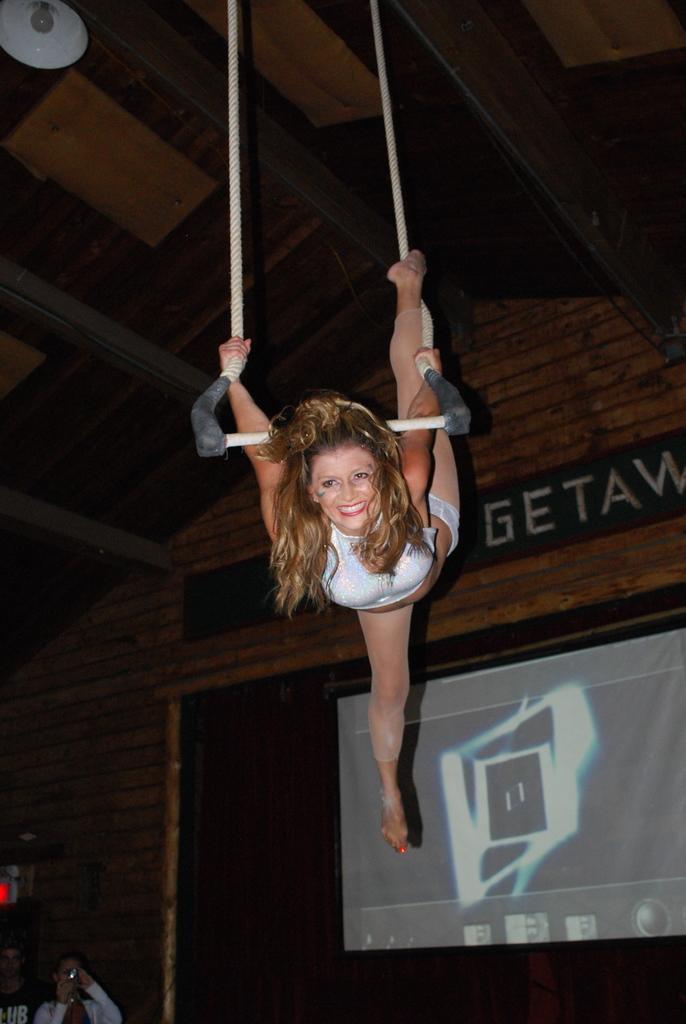Describe this image in one or two sentences. In this picture I can see there is a woman performing acrobatics and she is wearing a white dress and smiling, she is holding rope and there is a light attached to the ceiling and there are few persons standing at left and clicking pictures. 